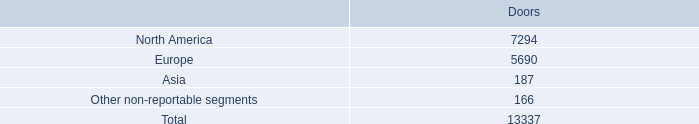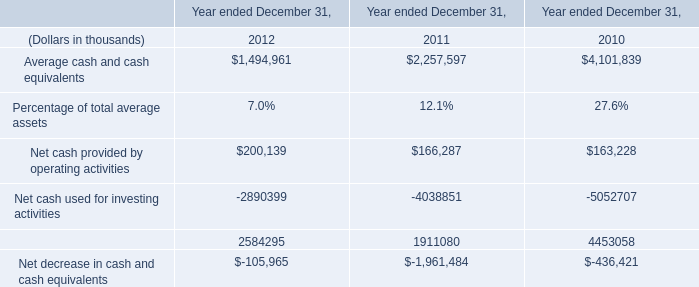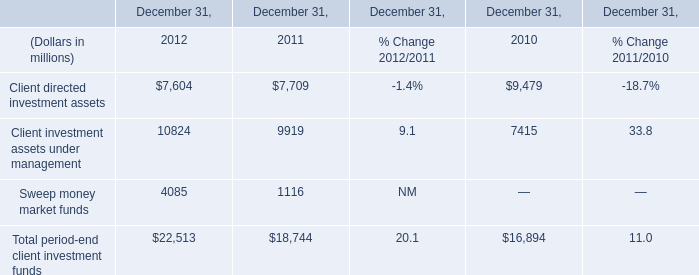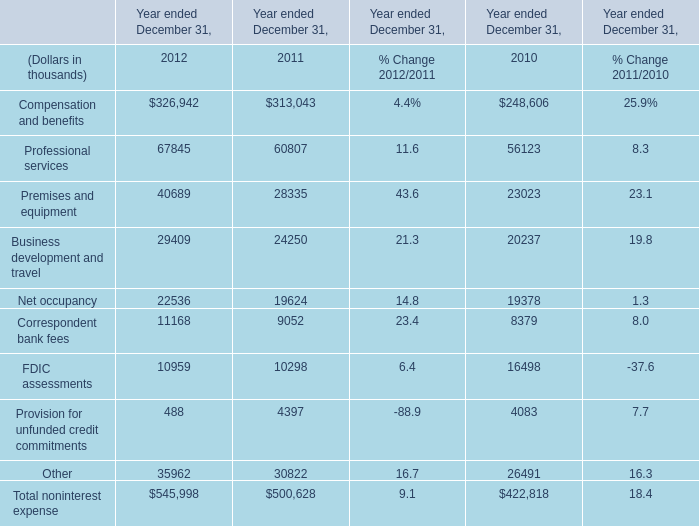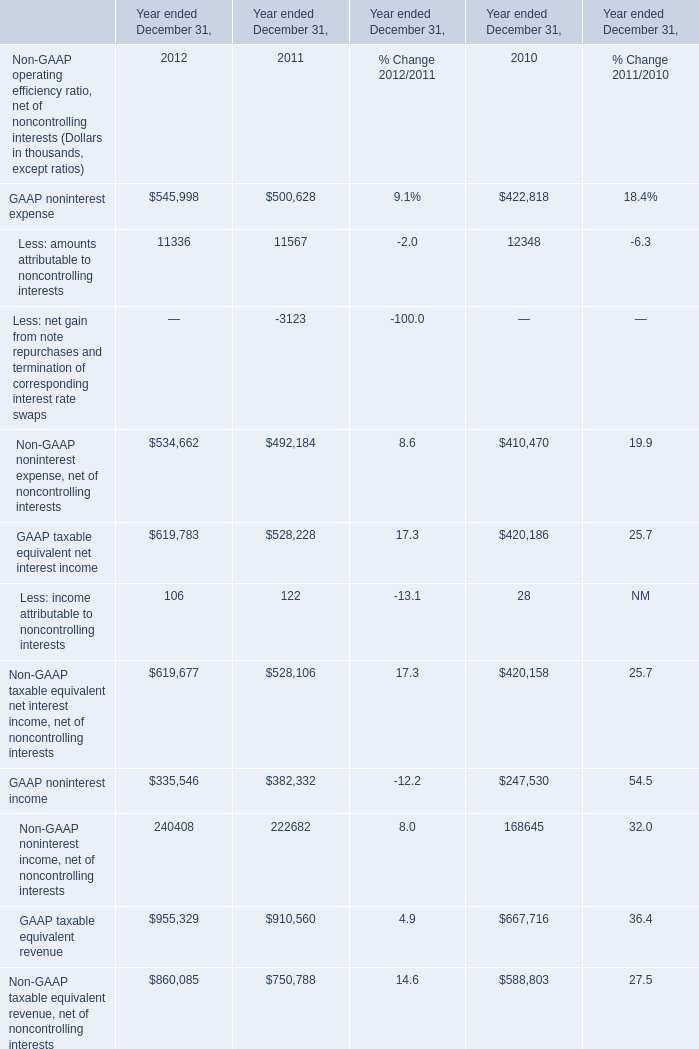In the year with largest amount of GAAP noninterest expense, what's the increasing rate of Non-GAAP noninterest expense, net of noncontrolling interests? 
Computations: ((534662 - 492184) / 534662)
Answer: 0.07945. 